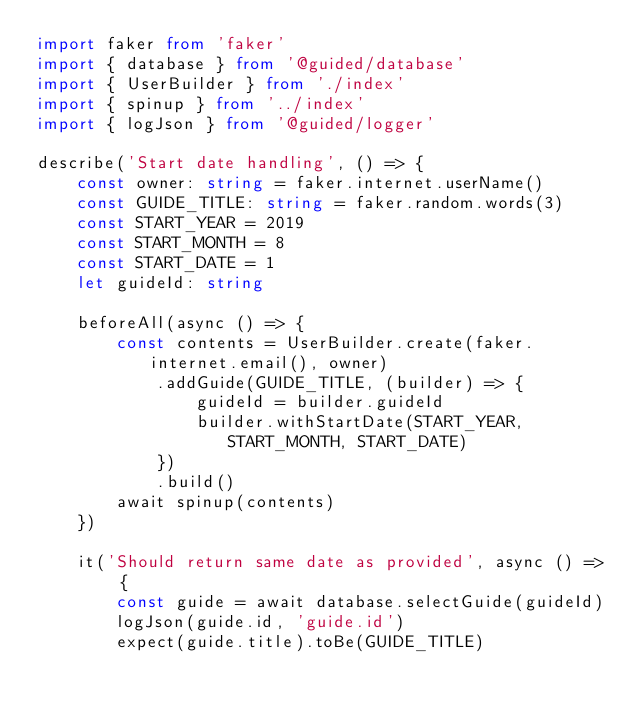Convert code to text. <code><loc_0><loc_0><loc_500><loc_500><_TypeScript_>import faker from 'faker'
import { database } from '@guided/database'
import { UserBuilder } from './index'
import { spinup } from '../index'
import { logJson } from '@guided/logger'

describe('Start date handling', () => {
    const owner: string = faker.internet.userName()
    const GUIDE_TITLE: string = faker.random.words(3)
    const START_YEAR = 2019
    const START_MONTH = 8
    const START_DATE = 1
    let guideId: string

    beforeAll(async () => {
        const contents = UserBuilder.create(faker.internet.email(), owner)
            .addGuide(GUIDE_TITLE, (builder) => {
                guideId = builder.guideId
                builder.withStartDate(START_YEAR, START_MONTH, START_DATE)
            })
            .build()
        await spinup(contents)
    })

    it('Should return same date as provided', async () => {
        const guide = await database.selectGuide(guideId)
        logJson(guide.id, 'guide.id')
        expect(guide.title).toBe(GUIDE_TITLE)</code> 